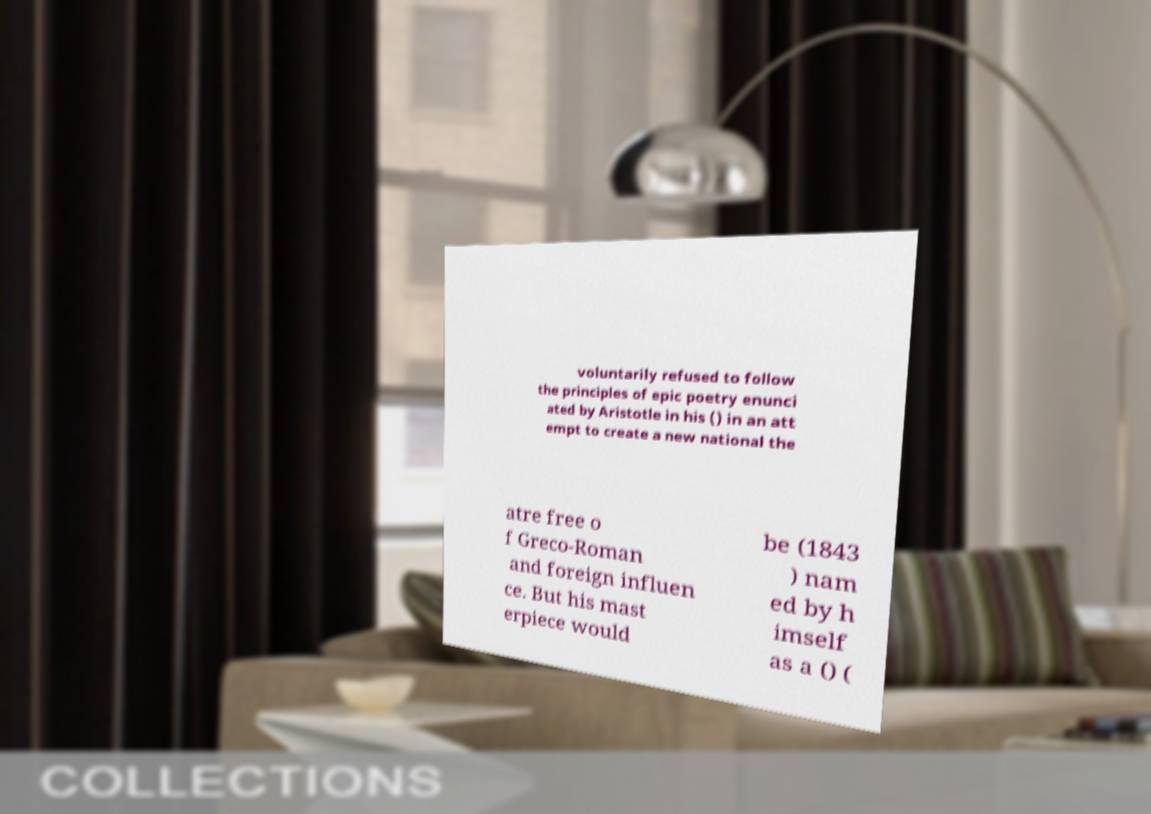I need the written content from this picture converted into text. Can you do that? voluntarily refused to follow the principles of epic poetry enunci ated by Aristotle in his () in an att empt to create a new national the atre free o f Greco-Roman and foreign influen ce. But his mast erpiece would be (1843 ) nam ed by h imself as a () ( 